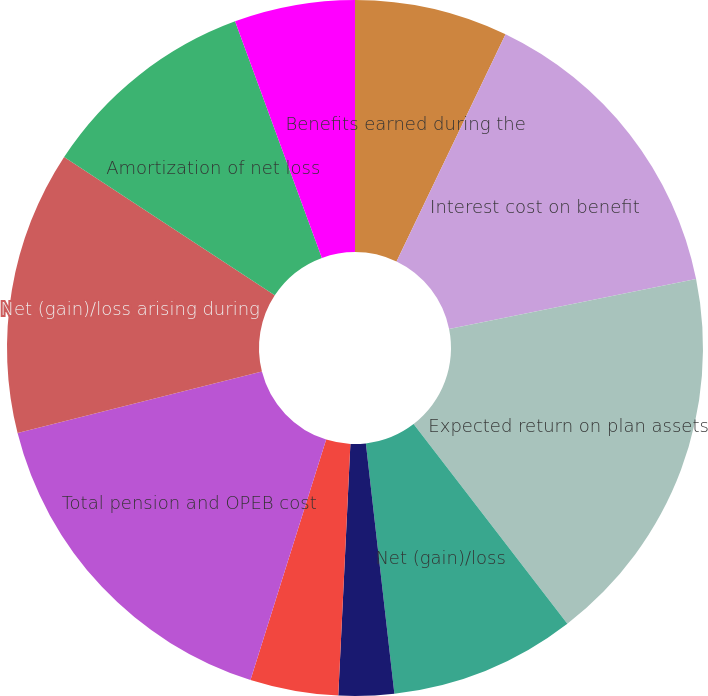Convert chart to OTSL. <chart><loc_0><loc_0><loc_500><loc_500><pie_chart><fcel>Benefits earned during the<fcel>Interest cost on benefit<fcel>Expected return on plan assets<fcel>Net (gain)/loss<fcel>Net periodic defined benefit<fcel>Total defined benefit plans<fcel>Total pension and OPEB cost<fcel>Net (gain)/loss arising during<fcel>Amortization of net loss<fcel>Total recognized in other<nl><fcel>7.12%<fcel>14.7%<fcel>17.73%<fcel>8.64%<fcel>2.57%<fcel>4.09%<fcel>16.21%<fcel>13.18%<fcel>10.15%<fcel>5.6%<nl></chart> 